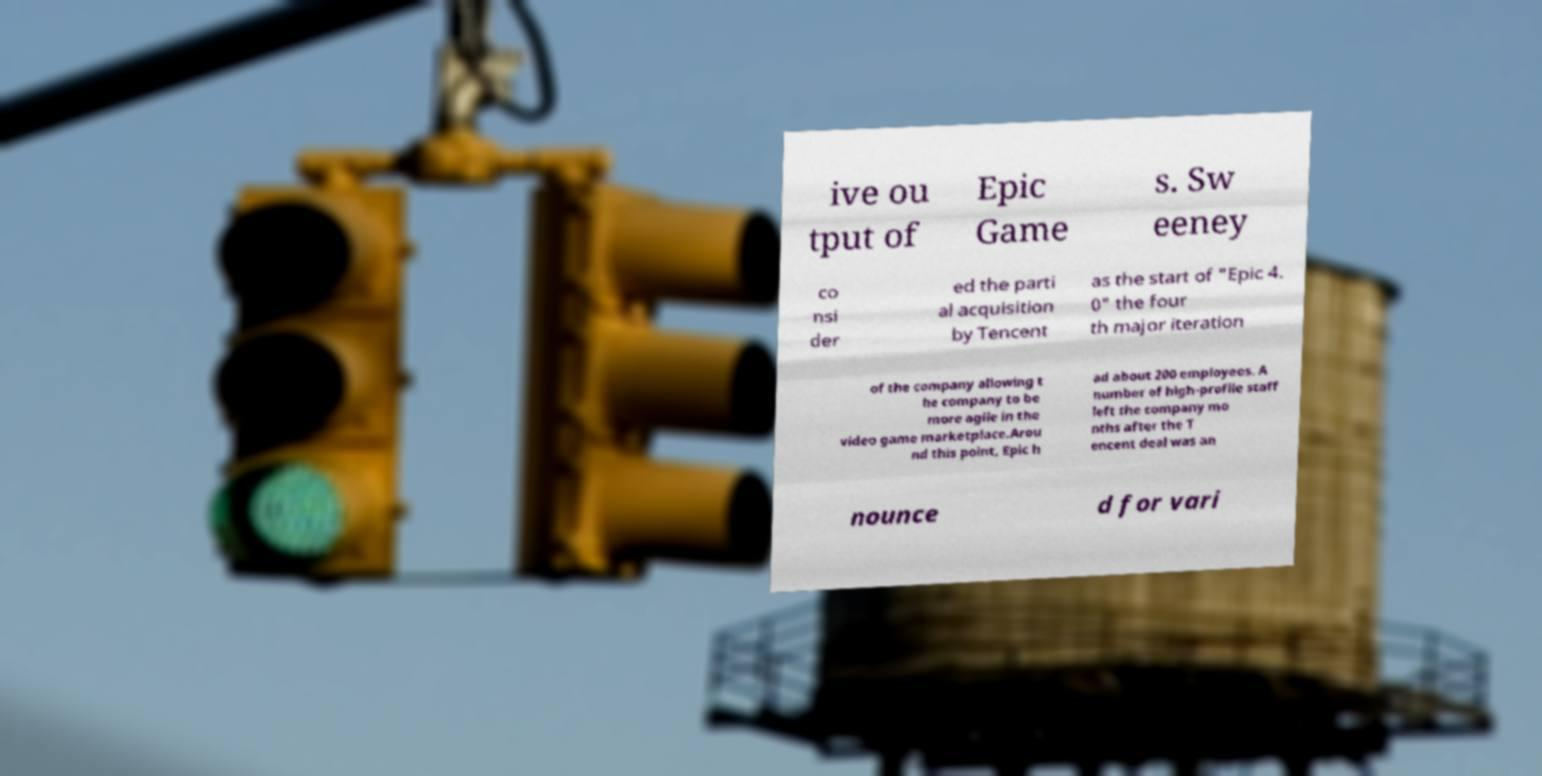Can you read and provide the text displayed in the image?This photo seems to have some interesting text. Can you extract and type it out for me? ive ou tput of Epic Game s. Sw eeney co nsi der ed the parti al acquisition by Tencent as the start of "Epic 4. 0" the four th major iteration of the company allowing t he company to be more agile in the video game marketplace.Arou nd this point, Epic h ad about 200 employees. A number of high-profile staff left the company mo nths after the T encent deal was an nounce d for vari 